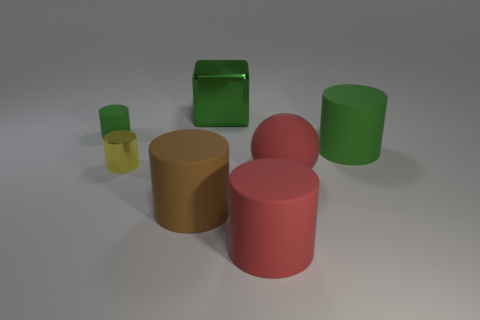Subtract 2 cylinders. How many cylinders are left? 3 Subtract all brown cylinders. How many cylinders are left? 4 Subtract all big brown cylinders. How many cylinders are left? 4 Subtract all purple cylinders. Subtract all brown balls. How many cylinders are left? 5 Add 1 red balls. How many objects exist? 8 Subtract all cubes. How many objects are left? 6 Subtract all large green matte cylinders. Subtract all big green shiny blocks. How many objects are left? 5 Add 6 big red spheres. How many big red spheres are left? 7 Add 5 large green metal blocks. How many large green metal blocks exist? 6 Subtract 0 blue blocks. How many objects are left? 7 